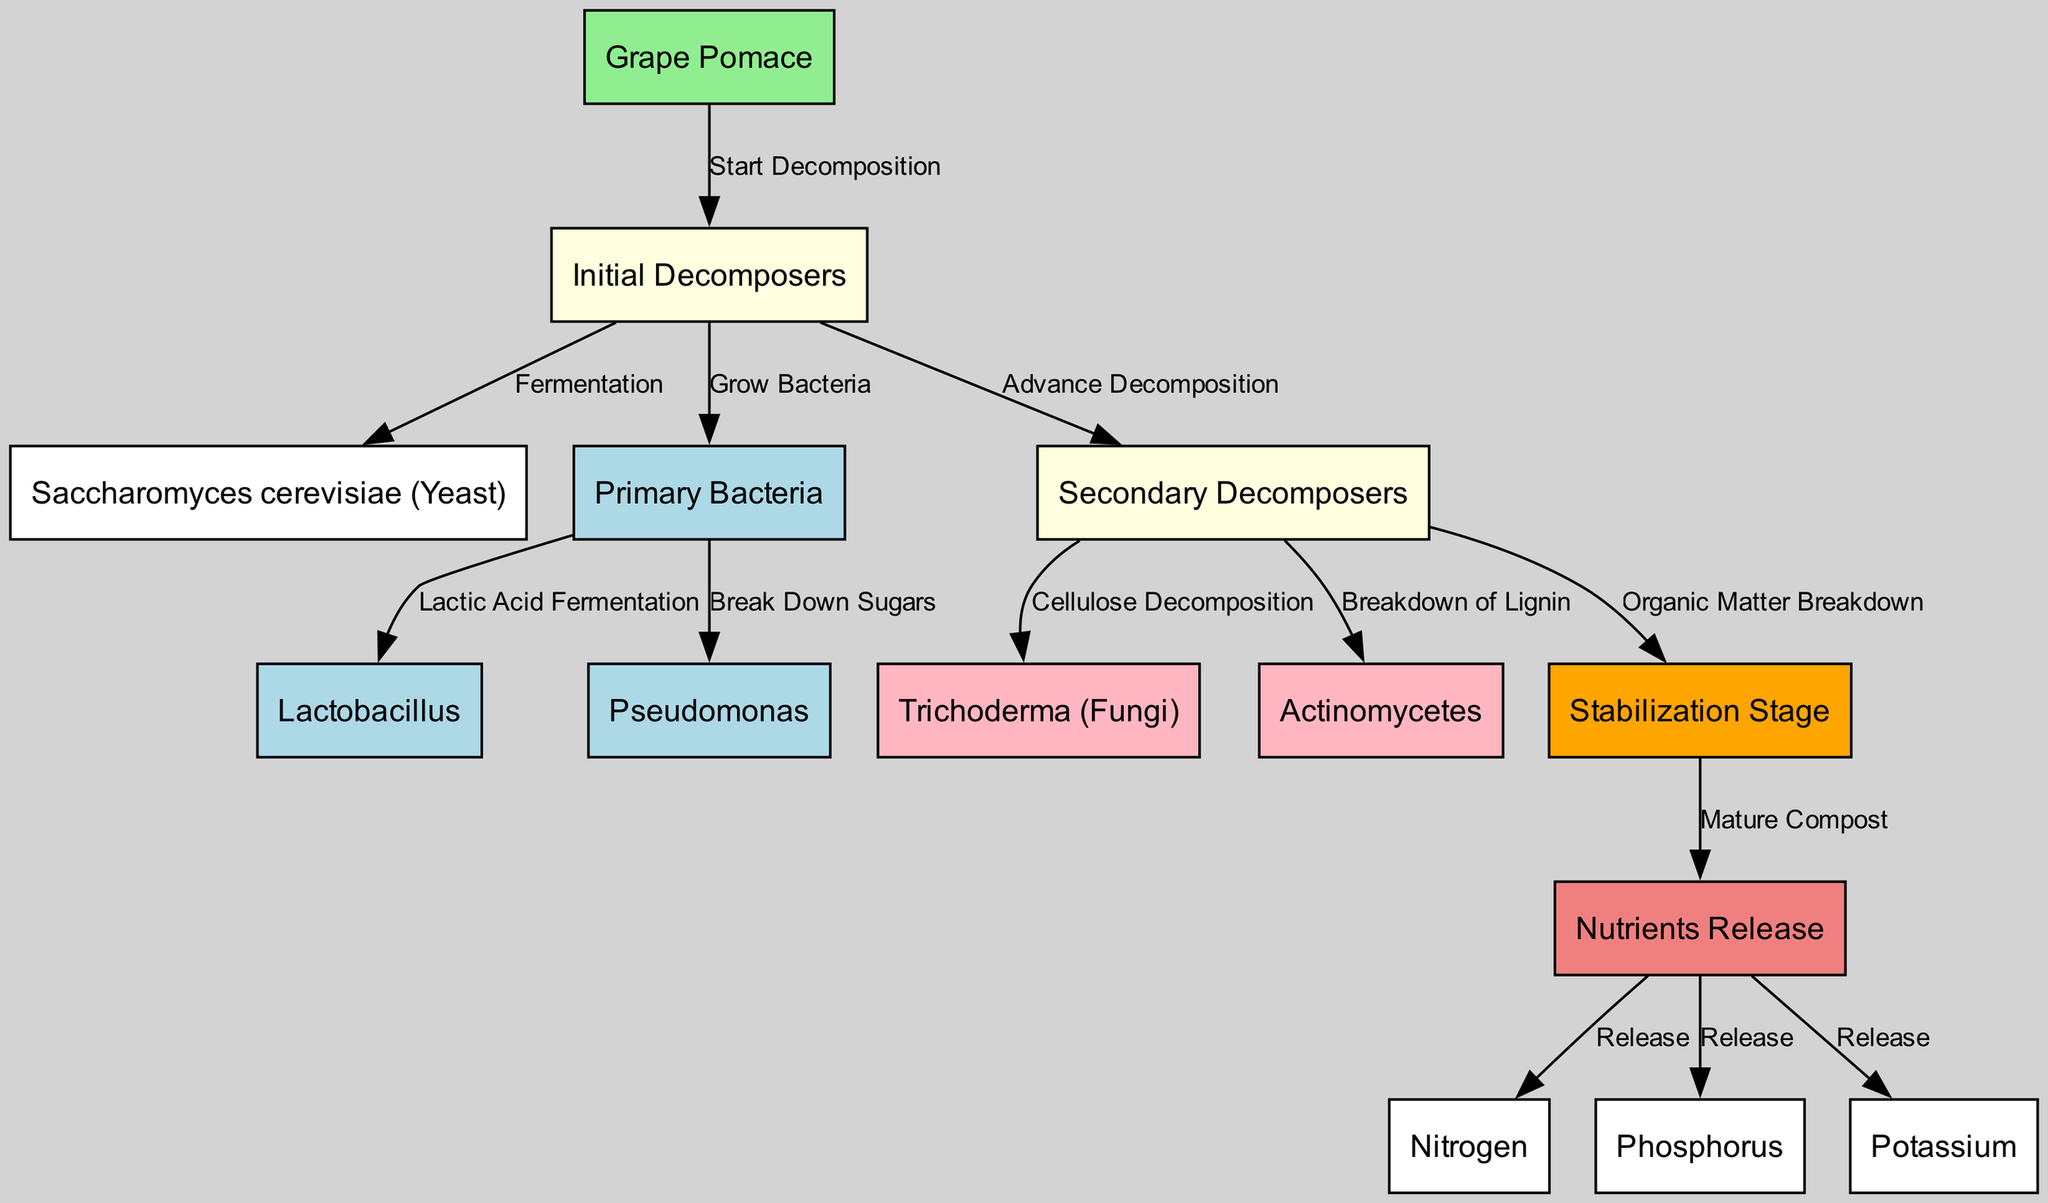What initiates the decomposition process in this diagram? The decomposition process starts with the node labeled "Grape Pomace", which is the source material for the microbial decomposition.
Answer: Grape Pomace How many types of primary bacteria are shown in the diagram? There are two types of primary bacteria in the diagram: "Lactobacillus" and "Pseudomonas". This can be verified by counting the corresponding nodes.
Answer: 2 What is the final stage before nutrient release? The final stage before the nutrients are released is identified as the "Stabilization Stage", which is connected to the "Nutrients Release" node.
Answer: Stabilization Stage Which organisms break down cellulose during decomposition? The organism responsible for cellulose decomposition is "Trichoderma (Fungi)", as indicated by the flow from "Secondary Decomposers" to "Fungi".
Answer: Trichoderma (Fungi) What nutrients are released during the composting process? The diagram details three specific nutrients released during the process: "Nitrogen", "Phosphorus", and "Potassium". This can be seen in the "Nutrients Release" node, which connects to these three nutrients.
Answer: Nitrogen, Phosphorus, Potassium What process do the initial decomposers undergo for fermentation? The initial decomposers enter the "Fermentation" process, leading to the involvement of "Saccharomyces cerevisiae (Yeast)", which is a type of yeast used in fermentation.
Answer: Fermentation Which type of bacteria is involved in lactic acid fermentation? "Lactobacillus" is the specific type of bacteria that is involved in lactic acid fermentation, as shown by the direct connection from "Primary Bacteria" to "Lactobacillus".
Answer: Lactobacillus What is the relationship between secondary decomposers and the stabilization stage? The secondary decomposers contribute by breaking down organic matter, which then leads to the "Stabilization Stage", indicating their role in the overall composting process.
Answer: Organic Matter Breakdown 